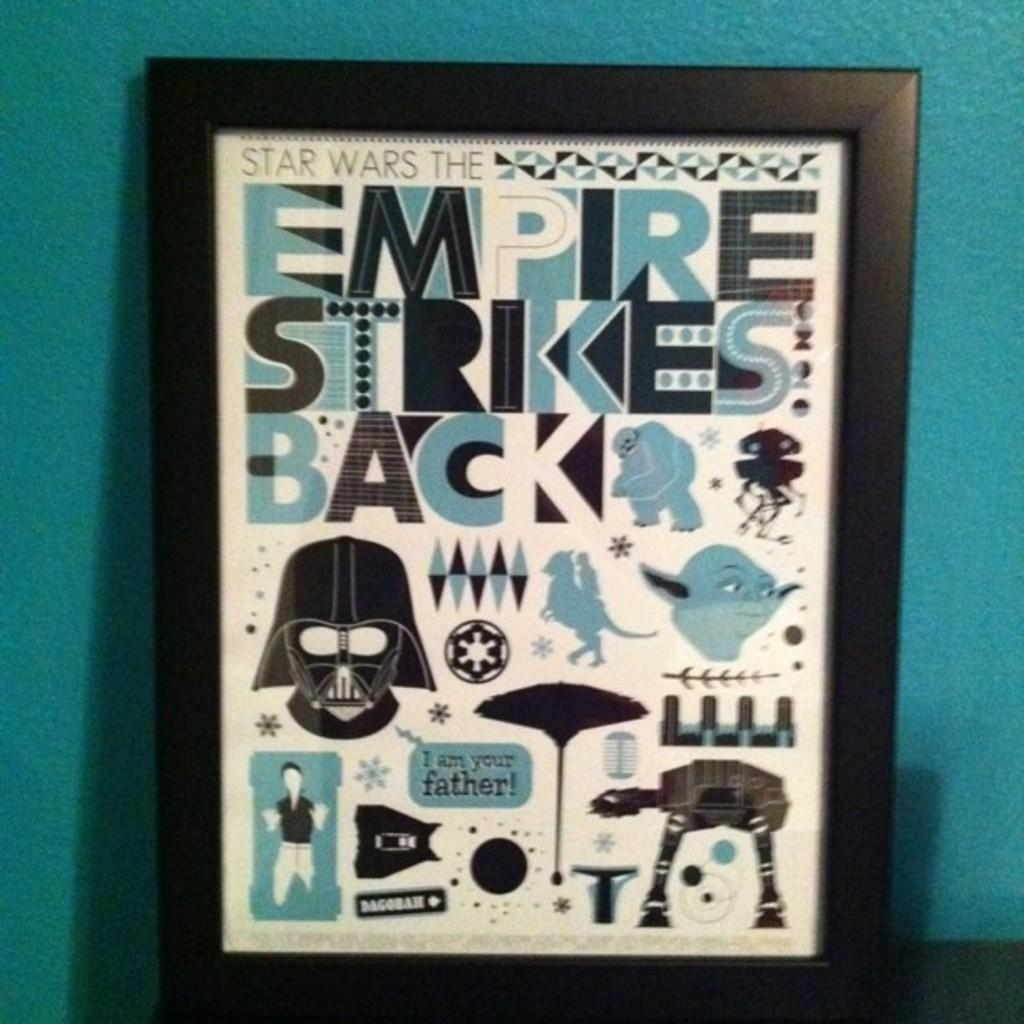<image>
Render a clear and concise summary of the photo. a frame with the title of Empire Strikes Back on it 